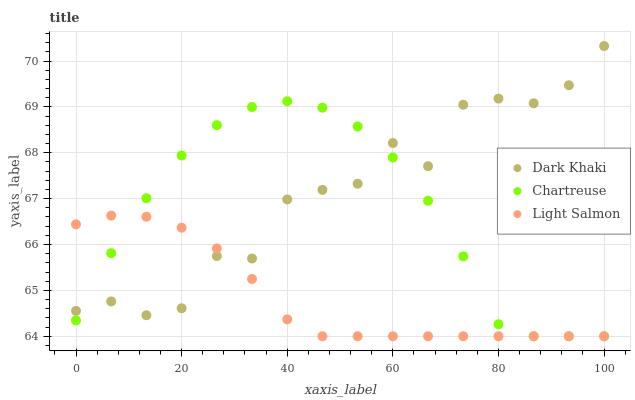Does Light Salmon have the minimum area under the curve?
Answer yes or no. Yes. Does Dark Khaki have the maximum area under the curve?
Answer yes or no. Yes. Does Chartreuse have the minimum area under the curve?
Answer yes or no. No. Does Chartreuse have the maximum area under the curve?
Answer yes or no. No. Is Light Salmon the smoothest?
Answer yes or no. Yes. Is Dark Khaki the roughest?
Answer yes or no. Yes. Is Chartreuse the smoothest?
Answer yes or no. No. Is Chartreuse the roughest?
Answer yes or no. No. Does Chartreuse have the lowest value?
Answer yes or no. Yes. Does Dark Khaki have the highest value?
Answer yes or no. Yes. Does Chartreuse have the highest value?
Answer yes or no. No. Does Chartreuse intersect Dark Khaki?
Answer yes or no. Yes. Is Chartreuse less than Dark Khaki?
Answer yes or no. No. Is Chartreuse greater than Dark Khaki?
Answer yes or no. No. 